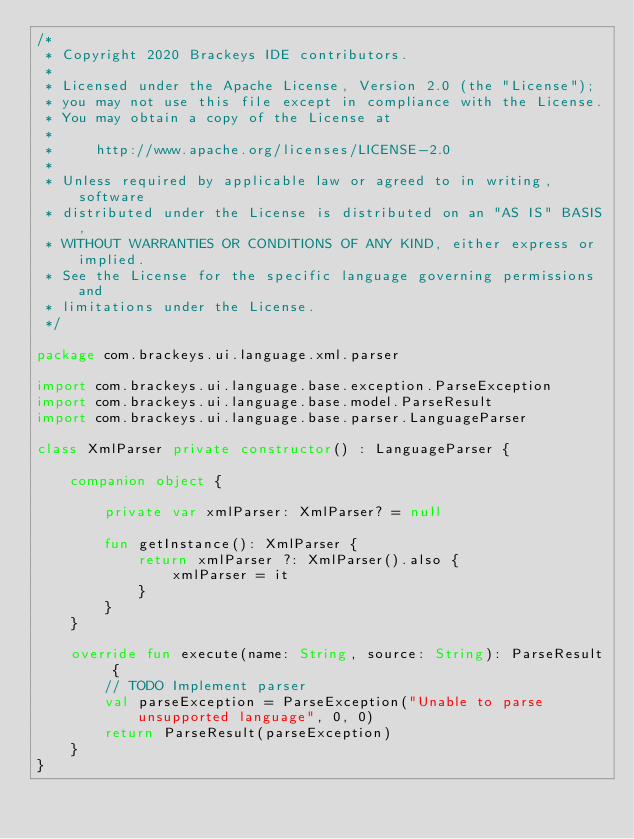Convert code to text. <code><loc_0><loc_0><loc_500><loc_500><_Kotlin_>/*
 * Copyright 2020 Brackeys IDE contributors.
 *
 * Licensed under the Apache License, Version 2.0 (the "License");
 * you may not use this file except in compliance with the License.
 * You may obtain a copy of the License at
 *
 *     http://www.apache.org/licenses/LICENSE-2.0
 *
 * Unless required by applicable law or agreed to in writing, software
 * distributed under the License is distributed on an "AS IS" BASIS,
 * WITHOUT WARRANTIES OR CONDITIONS OF ANY KIND, either express or implied.
 * See the License for the specific language governing permissions and
 * limitations under the License.
 */

package com.brackeys.ui.language.xml.parser

import com.brackeys.ui.language.base.exception.ParseException
import com.brackeys.ui.language.base.model.ParseResult
import com.brackeys.ui.language.base.parser.LanguageParser

class XmlParser private constructor() : LanguageParser {

    companion object {

        private var xmlParser: XmlParser? = null

        fun getInstance(): XmlParser {
            return xmlParser ?: XmlParser().also {
                xmlParser = it
            }
        }
    }

    override fun execute(name: String, source: String): ParseResult {
        // TODO Implement parser
        val parseException = ParseException("Unable to parse unsupported language", 0, 0)
        return ParseResult(parseException)
    }
}</code> 